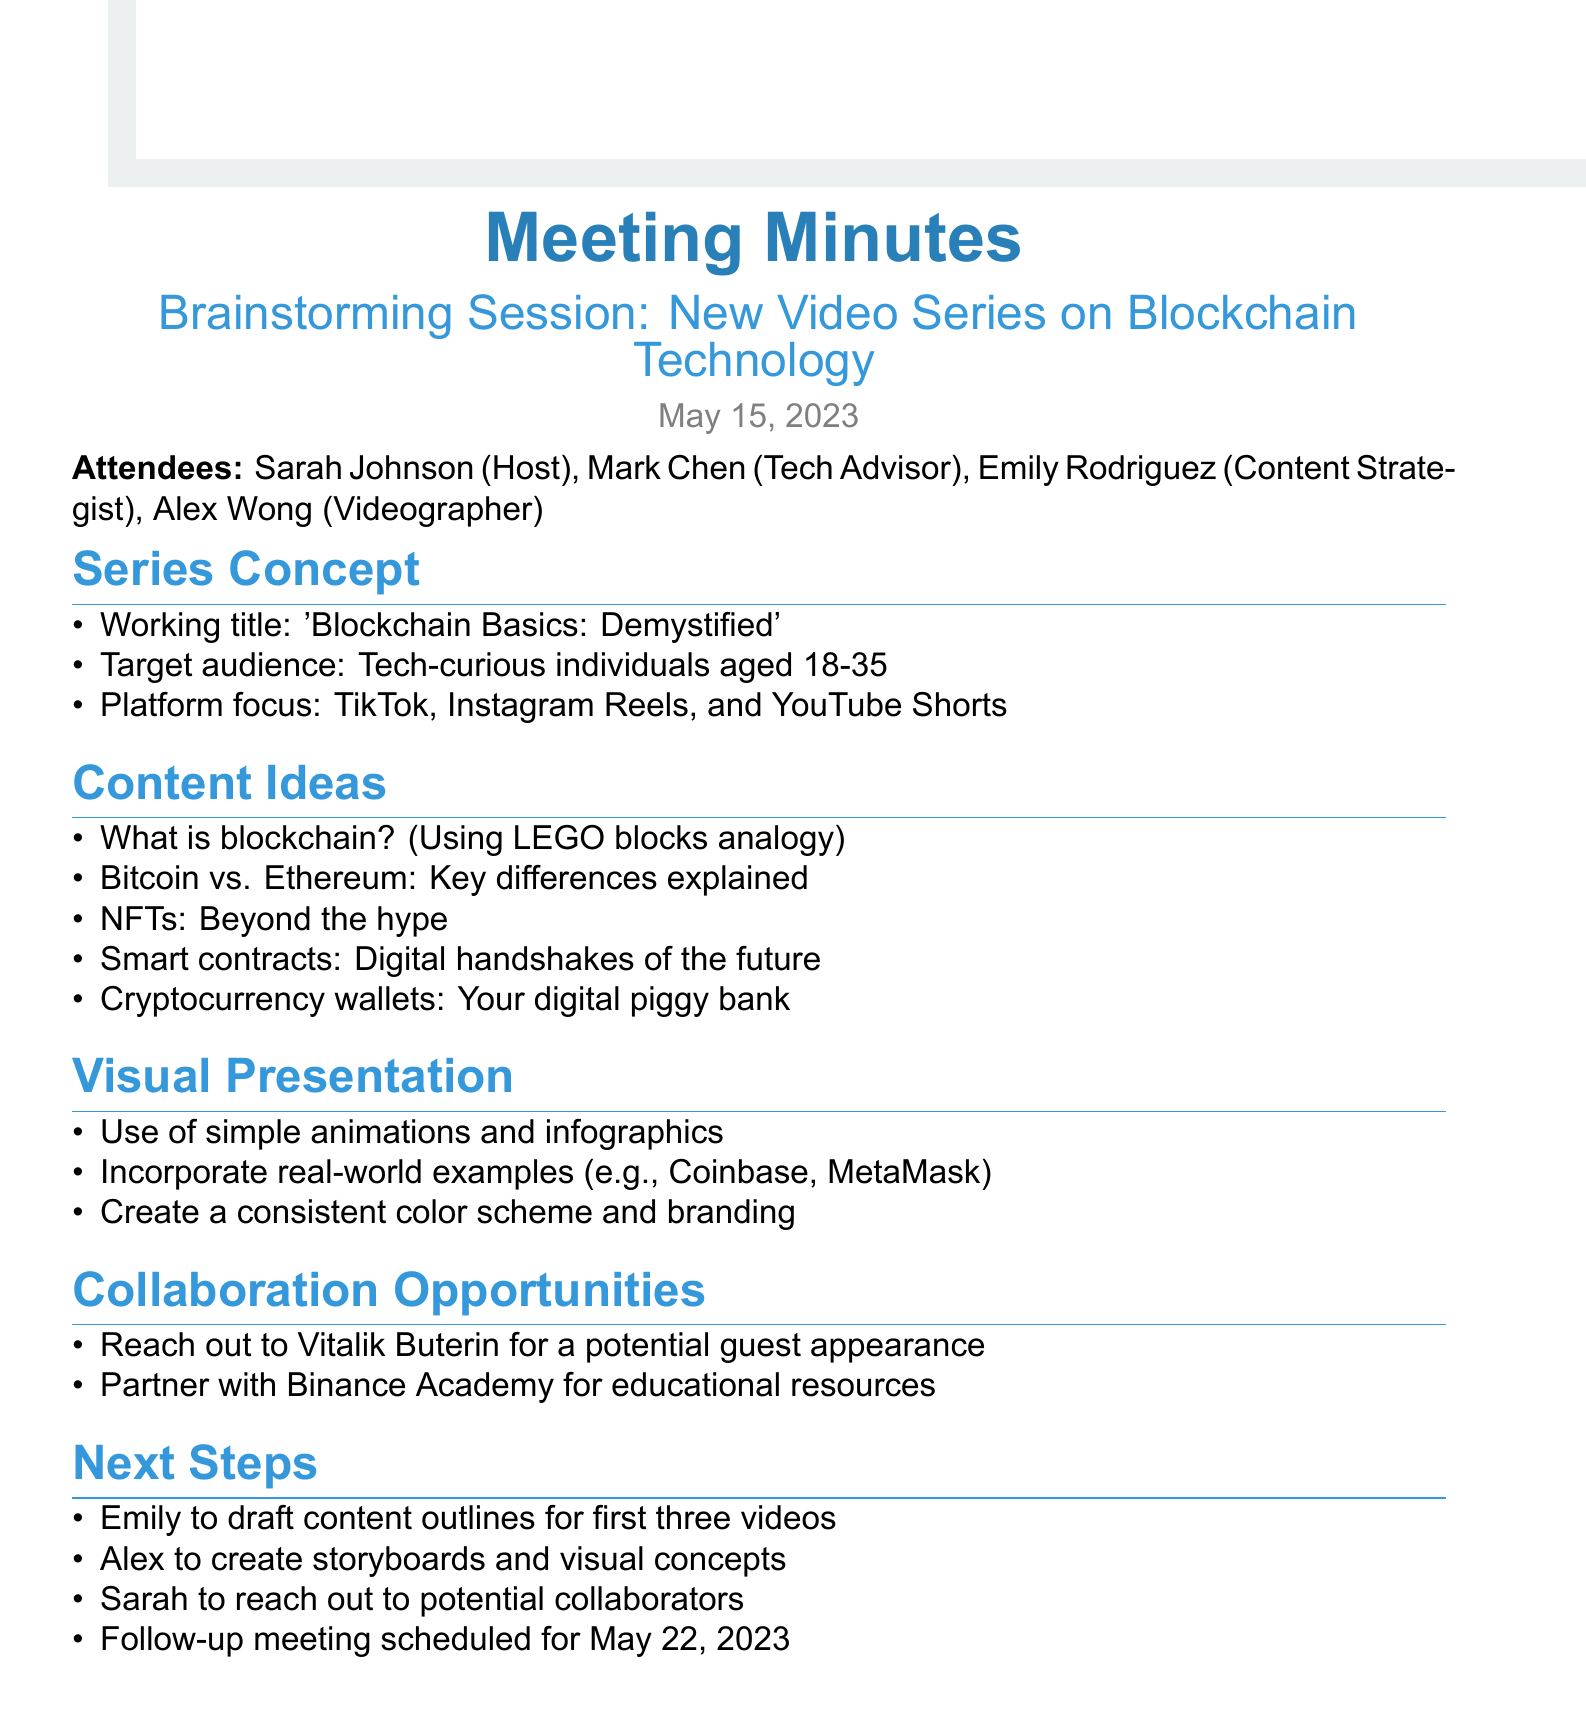What is the meeting title? The title is the heading of the meeting as mentioned in the document.
Answer: Brainstorming Session: New Video Series on Blockchain Technology Who is the host of the meeting? The host is the person who facilitated the meeting, as noted in the attendee list.
Answer: Sarah Johnson What is the working title of the video series? The working title provides a preliminary name for the series as discussed in the meeting.
Answer: Blockchain Basics: Demystified What is the target audience age range? The document specifies the intended demographic for the video series.
Answer: 18-35 What is one content idea discussed? This asks for any example of the topics that will be covered, as listed in the Content Ideas section.
Answer: What is blockchain? (Using LEGO blocks analogy) Who is to draft content outlines? This identifies who will be responsible for creating the outlines as mentioned in the next steps section.
Answer: Emily When is the follow-up meeting scheduled? This question is directed toward the date of the next scheduled meeting as stated in the document.
Answer: May 22, 2023 What visual presentation method is suggested? This seeks one example of how the content will be visually presented, as detailed in the Visual Presentation section.
Answer: Simple animations and infographics Name one collaboration opportunity mentioned. This asks for a specific collaboration mentioned in the discussion.
Answer: Vitalik Buterin for a potential guest appearance 